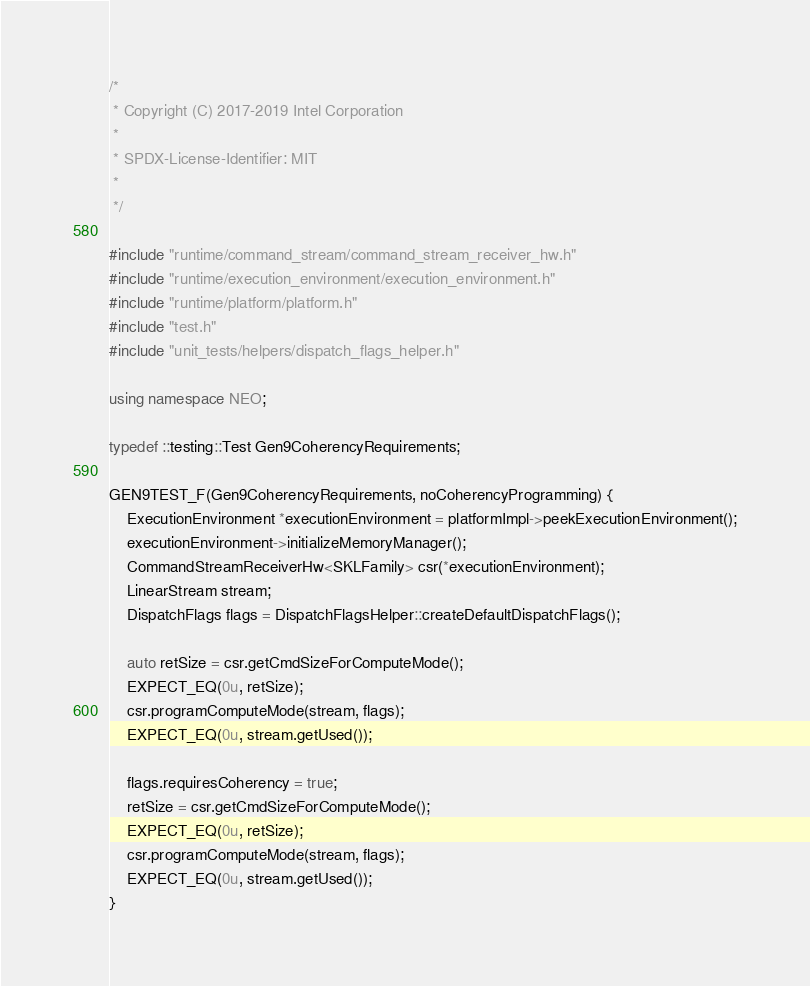Convert code to text. <code><loc_0><loc_0><loc_500><loc_500><_C++_>/*
 * Copyright (C) 2017-2019 Intel Corporation
 *
 * SPDX-License-Identifier: MIT
 *
 */

#include "runtime/command_stream/command_stream_receiver_hw.h"
#include "runtime/execution_environment/execution_environment.h"
#include "runtime/platform/platform.h"
#include "test.h"
#include "unit_tests/helpers/dispatch_flags_helper.h"

using namespace NEO;

typedef ::testing::Test Gen9CoherencyRequirements;

GEN9TEST_F(Gen9CoherencyRequirements, noCoherencyProgramming) {
    ExecutionEnvironment *executionEnvironment = platformImpl->peekExecutionEnvironment();
    executionEnvironment->initializeMemoryManager();
    CommandStreamReceiverHw<SKLFamily> csr(*executionEnvironment);
    LinearStream stream;
    DispatchFlags flags = DispatchFlagsHelper::createDefaultDispatchFlags();

    auto retSize = csr.getCmdSizeForComputeMode();
    EXPECT_EQ(0u, retSize);
    csr.programComputeMode(stream, flags);
    EXPECT_EQ(0u, stream.getUsed());

    flags.requiresCoherency = true;
    retSize = csr.getCmdSizeForComputeMode();
    EXPECT_EQ(0u, retSize);
    csr.programComputeMode(stream, flags);
    EXPECT_EQ(0u, stream.getUsed());
}
</code> 